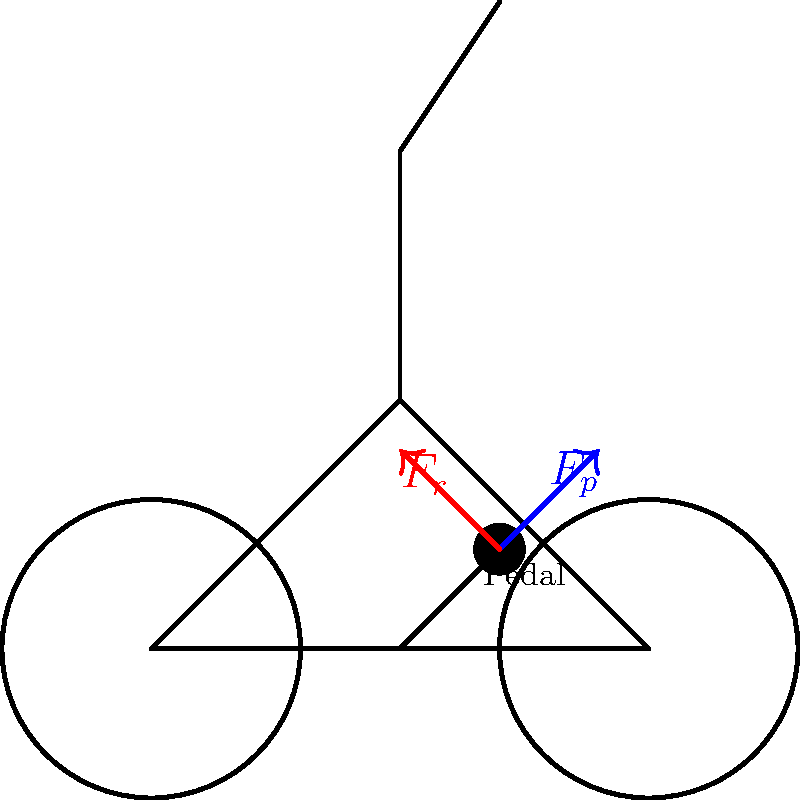In the context of biomechanics in cycling, consider the forces acting on a cyclist's legs during pedaling. The diagram shows a simplified representation of a bike and rider, with two forces indicated: $F_p$ (blue arrow) and $F_r$ (red arrow). Which force represents the resistance that the cyclist must overcome, and how does this relate to the concept of "le Tour de Force" often used in French cinema to describe a powerful performance? To answer this question, let's break down the forces and their implications:

1. Force $F_p$ (blue arrow):
   - This represents the propulsive force applied by the cyclist to the pedal.
   - It's directed downward and forward, indicating the direction of pedal movement.

2. Force $F_r$ (red arrow):
   - This represents the resistive force that opposes the cyclist's motion.
   - It's directed upward and backward, countering the propulsive force.

3. The resistive force $F_r$ is the one the cyclist must overcome. This includes:
   - Air resistance
   - Rolling resistance of the tires
   - Gravitational force when climbing

4. Relating to "le Tour de Force" in French cinema:
   - "Tour de Force" literally means "feat of strength" or "masterstroke" in French.
   - In cinema, it often refers to a powerful, impressive performance by an actor.
   - In cycling, overcoming the resistive force $F_r$ requires significant effort and strength, especially during challenging stages of races like the Tour de France.
   - The cyclist's ability to consistently overcome this resistance throughout a race can be seen as a "Tour de Force" in the sporting world.

5. The connection between biomechanics and cinematic storytelling:
   - Both involve overcoming resistance (physical in cycling, narrative obstacles in film) to achieve a goal.
   - The visual representation of force in the diagram parallels the visual storytelling in cinema.
   - Understanding the forces at play enhances appreciation of both the athletic feat in cycling and the narrative achievements in French cinema.
Answer: $F_r$ (resistive force); parallels the challenging obstacles overcome in cinematic "Tour de Force" performances. 